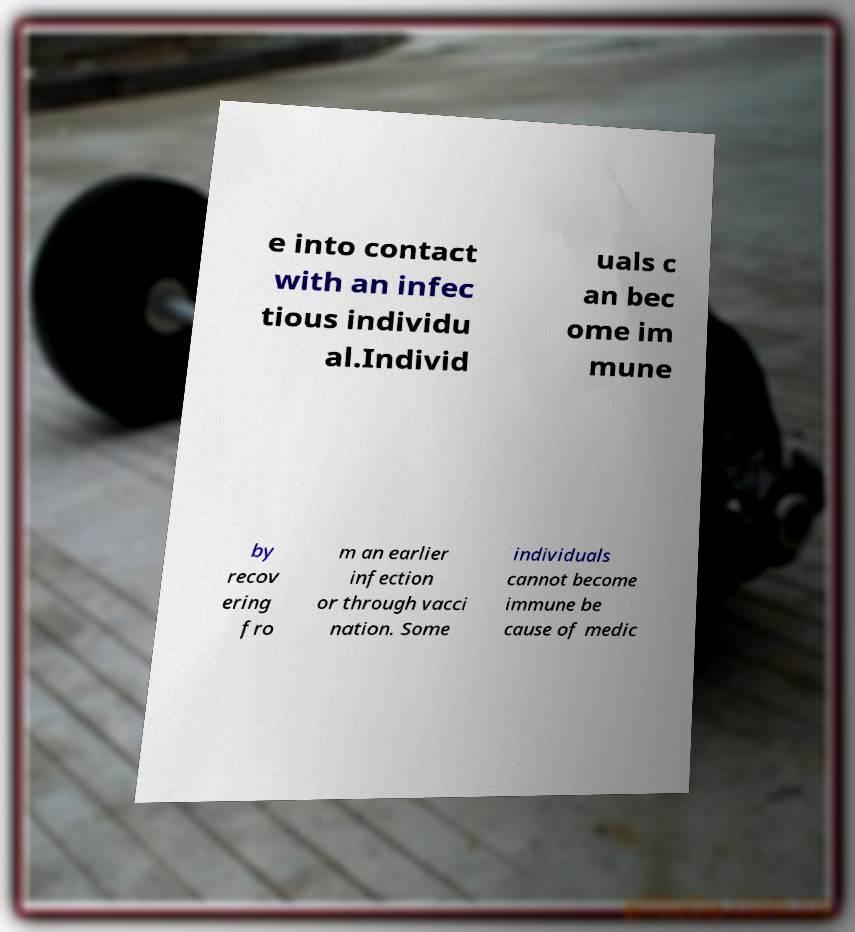Could you extract and type out the text from this image? e into contact with an infec tious individu al.Individ uals c an bec ome im mune by recov ering fro m an earlier infection or through vacci nation. Some individuals cannot become immune be cause of medic 